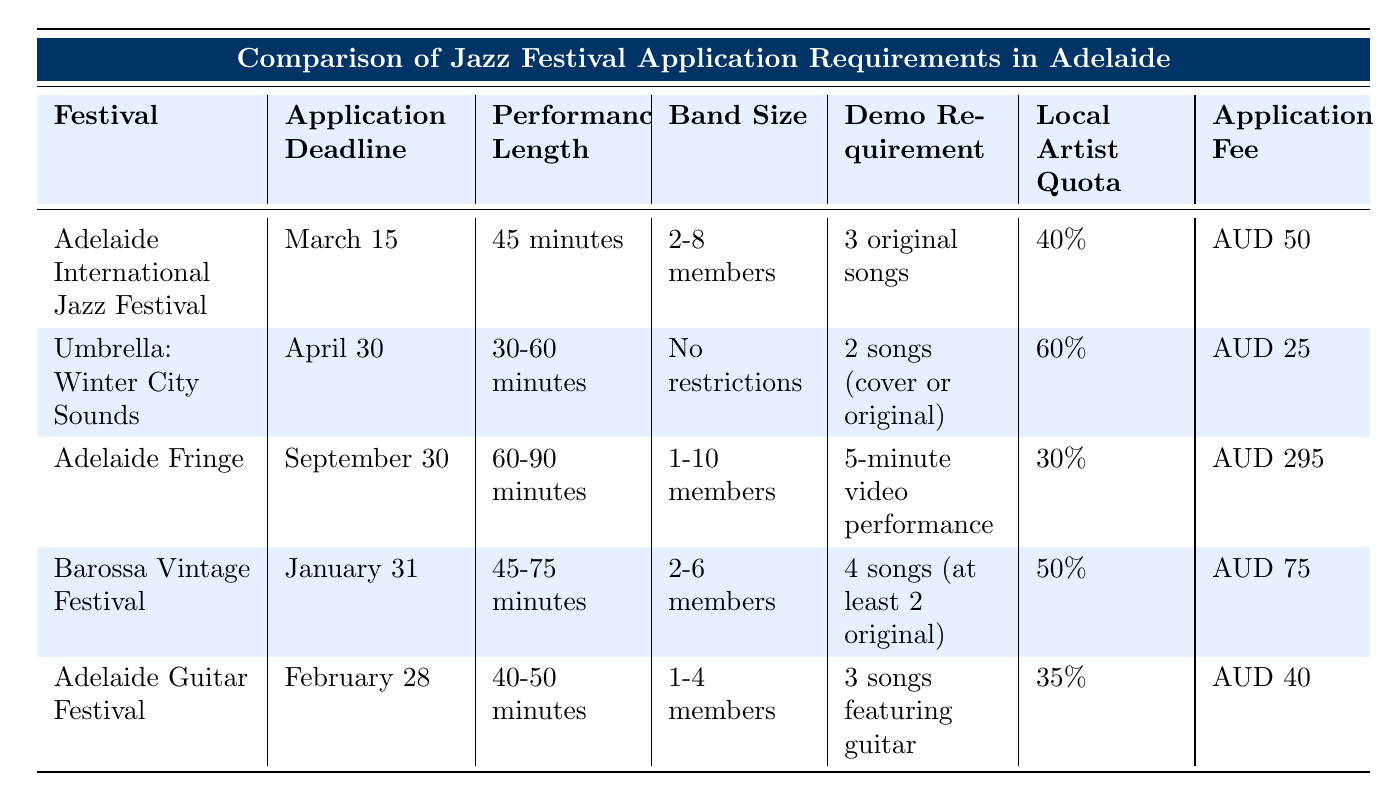What is the application deadline for the Adelaide International Jazz Festival? The application deadline for the Adelaide International Jazz Festival is clearly stated in the table under the corresponding festival's row. It is listed as March 15.
Answer: March 15 How many songs does the Umbrella: Winter City Sounds require for a demo? In the table, under the Umbrella: Winter City Sounds row, it specifies the demo requirement as 2 songs, and they can be cover or original.
Answer: 2 songs (cover or original) Which festival has the longest performance length requirement? The table shows the performance lengths for each festival. Adelaide Fringe is listed with a performance length of 60-90 minutes, which is the longest duration compared to the others.
Answer: Adelaide Fringe What is the average application fee for these festivals? To calculate the average application fee, we first sum the fees: AUD 50 + AUD 25 + AUD 295 + AUD 75 + AUD 40 = AUD 485. There are 5 festivals, so we divide AUD 485 by 5, which equals AUD 97.
Answer: AUD 97 Is there a local artist quota for the Adelaide Guitar Festival? The table indicates a local artist quota for each festival. The Adelaide Guitar Festival has a local artist quota of 35%, which confirms that there is a quota in place.
Answer: Yes Does the Barossa Vintage Festival have a minimum previous experience requirement? The Barossa Vintage Festival row in the table states that there is a requirement of at least 1 year of performing experience. Thus, the answer is affirmative.
Answer: Yes Which festival has an application fee lower than AUD 50? By reviewing the application fee column in the table, both the Umbrella: Winter City Sounds (AUD 25) and the Adelaide Guitar Festival (AUD 40) have fees that are lower than AUD 50.
Answer: Umbrella: Winter City Sounds and Adelaide Guitar Festival What percentage of slots are reserved for local artists at the Adelaide International Jazz Festival and the Barossa Vintage Festival combined? The local artist quota for the Adelaide International Jazz Festival is 40%, and for the Barossa Vintage Festival, it is 50%. Combining these, we get 40% + 50% = 90%.
Answer: 90% What is the band size limit for the Umbrella: Winter City Sounds festival? In the table under the Umbrella: Winter City Sounds row, it clearly states that there are no restrictions on band size, implying any number of members can apply.
Answer: No restrictions 